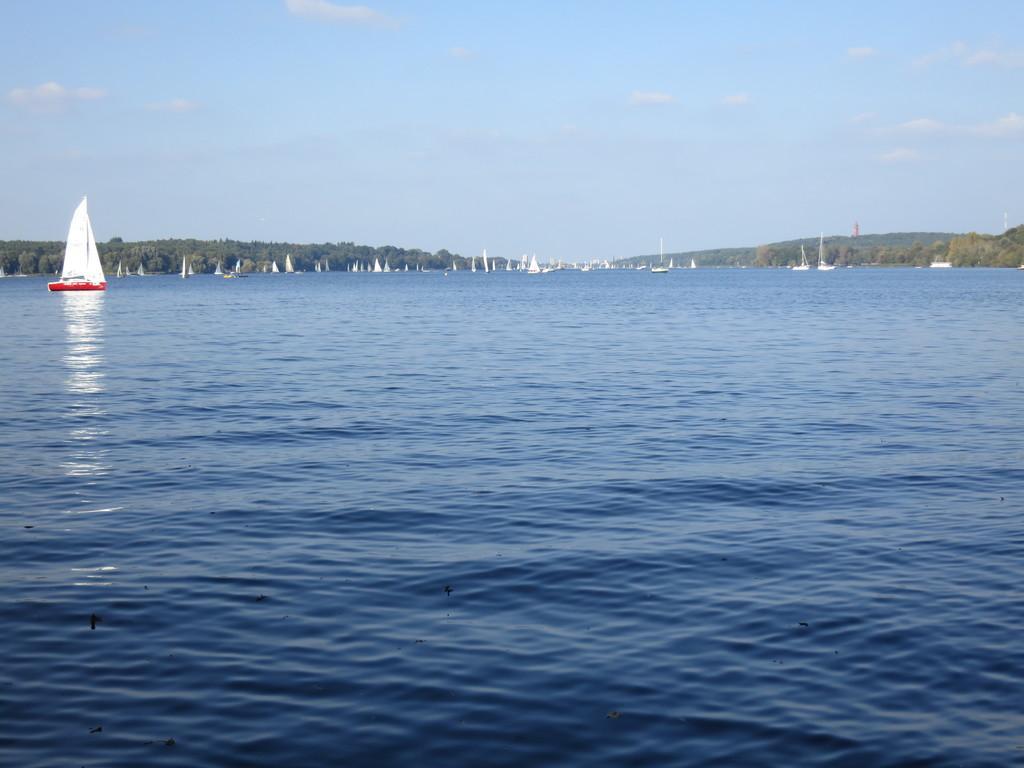Describe this image in one or two sentences. In this image I can see a boat which is red and white in color is on the water and in the background I can see number of boats in the water, few trees and the sky. 